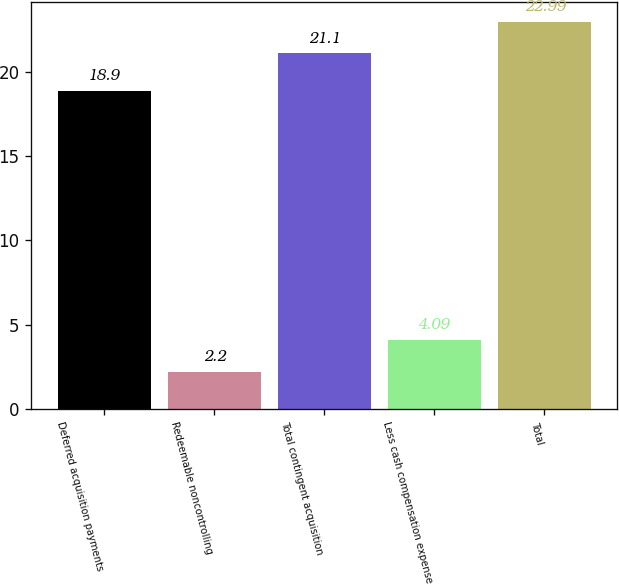Convert chart to OTSL. <chart><loc_0><loc_0><loc_500><loc_500><bar_chart><fcel>Deferred acquisition payments<fcel>Redeemable noncontrolling<fcel>Total contingent acquisition<fcel>Less cash compensation expense<fcel>Total<nl><fcel>18.9<fcel>2.2<fcel>21.1<fcel>4.09<fcel>22.99<nl></chart> 